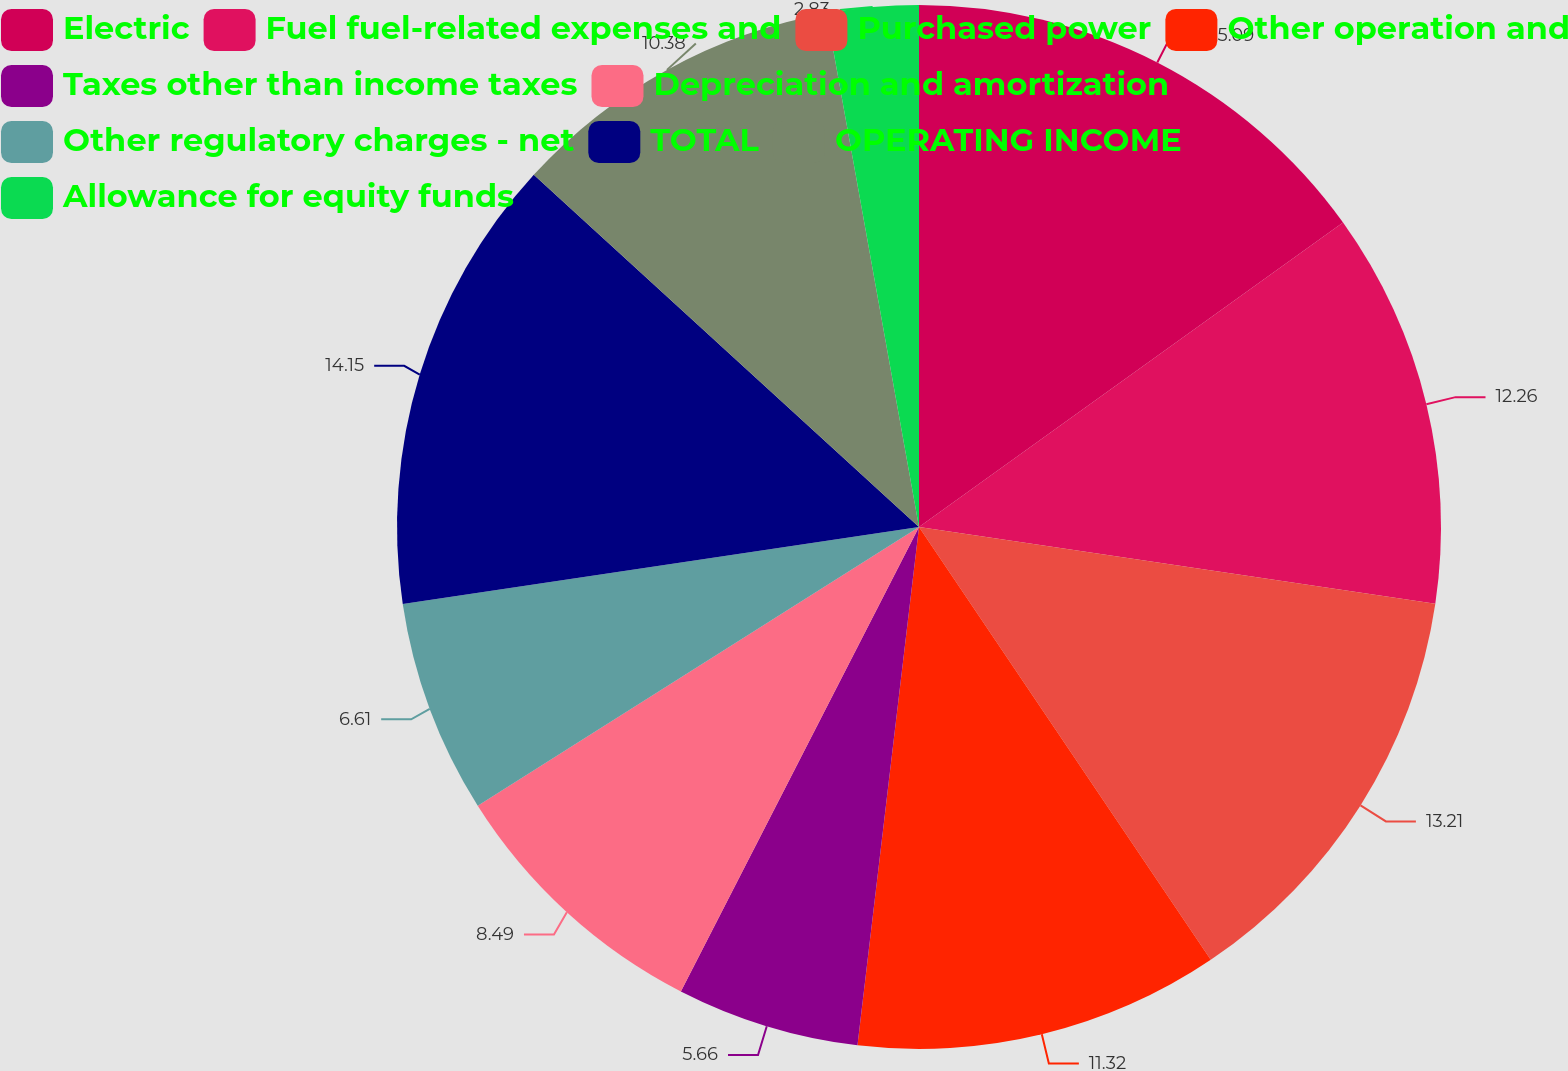Convert chart. <chart><loc_0><loc_0><loc_500><loc_500><pie_chart><fcel>Electric<fcel>Fuel fuel-related expenses and<fcel>Purchased power<fcel>Other operation and<fcel>Taxes other than income taxes<fcel>Depreciation and amortization<fcel>Other regulatory charges - net<fcel>TOTAL<fcel>OPERATING INCOME<fcel>Allowance for equity funds<nl><fcel>15.09%<fcel>12.26%<fcel>13.21%<fcel>11.32%<fcel>5.66%<fcel>8.49%<fcel>6.61%<fcel>14.15%<fcel>10.38%<fcel>2.83%<nl></chart> 